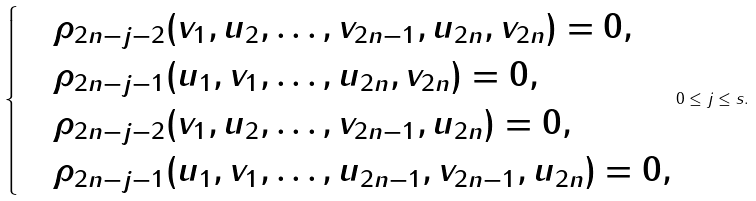<formula> <loc_0><loc_0><loc_500><loc_500>\begin{cases} & \rho _ { 2 n - j - 2 } ( v _ { 1 } , u _ { 2 } , \dots , v _ { 2 n - 1 } , u _ { 2 n } , v _ { 2 n } ) = 0 , \\ & \rho _ { 2 n - j - 1 } ( u _ { 1 } , v _ { 1 } , \dots , u _ { 2 n } , v _ { 2 n } ) = 0 , \\ & \rho _ { 2 n - j - 2 } ( v _ { 1 } , u _ { 2 } , \dots , v _ { 2 n - 1 } , u _ { 2 n } ) = 0 , \\ & \rho _ { 2 n - j - 1 } ( u _ { 1 } , v _ { 1 } , \dots , u _ { 2 n - 1 } , v _ { 2 n - 1 } , u _ { 2 n } ) = 0 , \end{cases} 0 \leq j \leq s .</formula> 